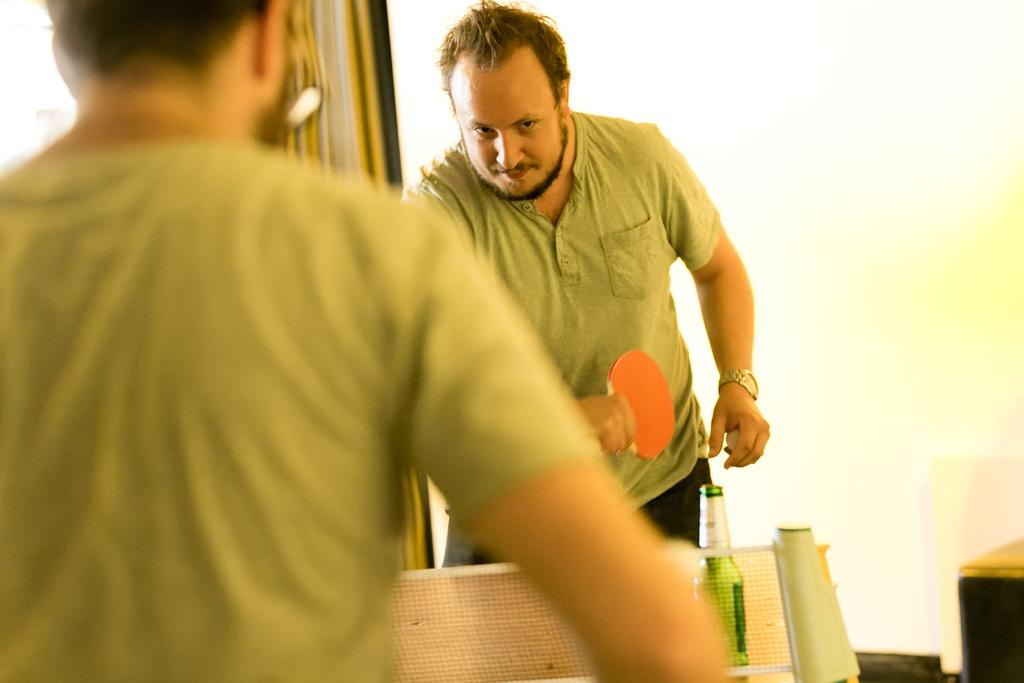What activity are the two persons engaged in? The two persons are playing table tennis. What color are the t-shirts worn by both persons? Both persons are wearing olive green t-shirts. Can you identify any other objects in the image? Yes, there is a liquor bottle in the image. Which person is holding a bat? One person is holding a bat. What type of yoke is being used by the players in the image? There is no yoke present in the image; the activity is table tennis, which does not involve a yoke. What type of linen can be seen draped over the table in the image? There is no linen draped over the table in the image. 